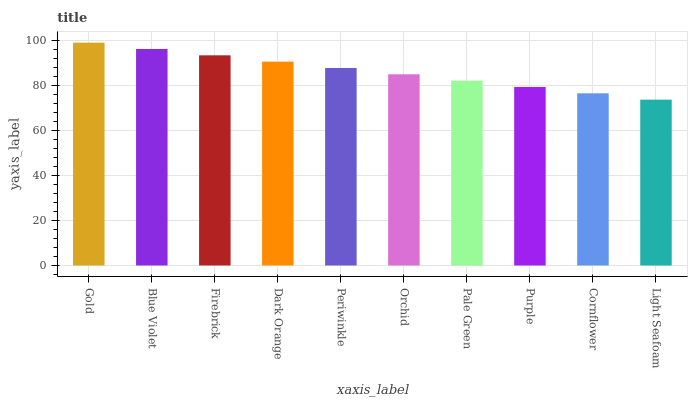Is Light Seafoam the minimum?
Answer yes or no. Yes. Is Gold the maximum?
Answer yes or no. Yes. Is Blue Violet the minimum?
Answer yes or no. No. Is Blue Violet the maximum?
Answer yes or no. No. Is Gold greater than Blue Violet?
Answer yes or no. Yes. Is Blue Violet less than Gold?
Answer yes or no. Yes. Is Blue Violet greater than Gold?
Answer yes or no. No. Is Gold less than Blue Violet?
Answer yes or no. No. Is Periwinkle the high median?
Answer yes or no. Yes. Is Orchid the low median?
Answer yes or no. Yes. Is Blue Violet the high median?
Answer yes or no. No. Is Pale Green the low median?
Answer yes or no. No. 